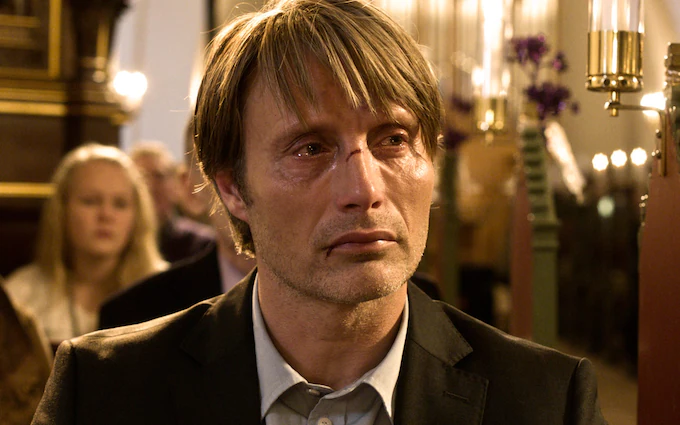What could be a completely fantastical explanation for the image? The man in the image is actually an ancient sorcerer who has lived for centuries, protecting humanity from unseen magical threats. The church is a sacred ground, where the veil between dimensions is thinnest. Today, he has come to this hallowed place to perform an age-old ritual that will seal a dangerous rift in the magical fabric of the world. The tears in his eyes reflect the immense burden he has carried for countless lifetimes and the toll this final act of sacrifice will take on his very soul. As he gazes sideways, he is not looking at the gathered people, but at the spectral beings from other realms who have come to witness this monumental event. 